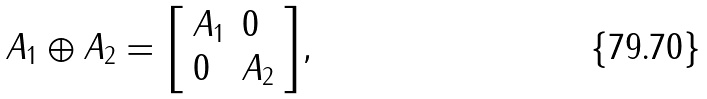<formula> <loc_0><loc_0><loc_500><loc_500>A _ { 1 } \oplus A _ { 2 } = { \left [ \begin{array} { l l } { A _ { 1 } } & { 0 } \\ { 0 } & { A _ { 2 } } \end{array} \right ] } ,</formula> 